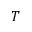<formula> <loc_0><loc_0><loc_500><loc_500>T</formula> 